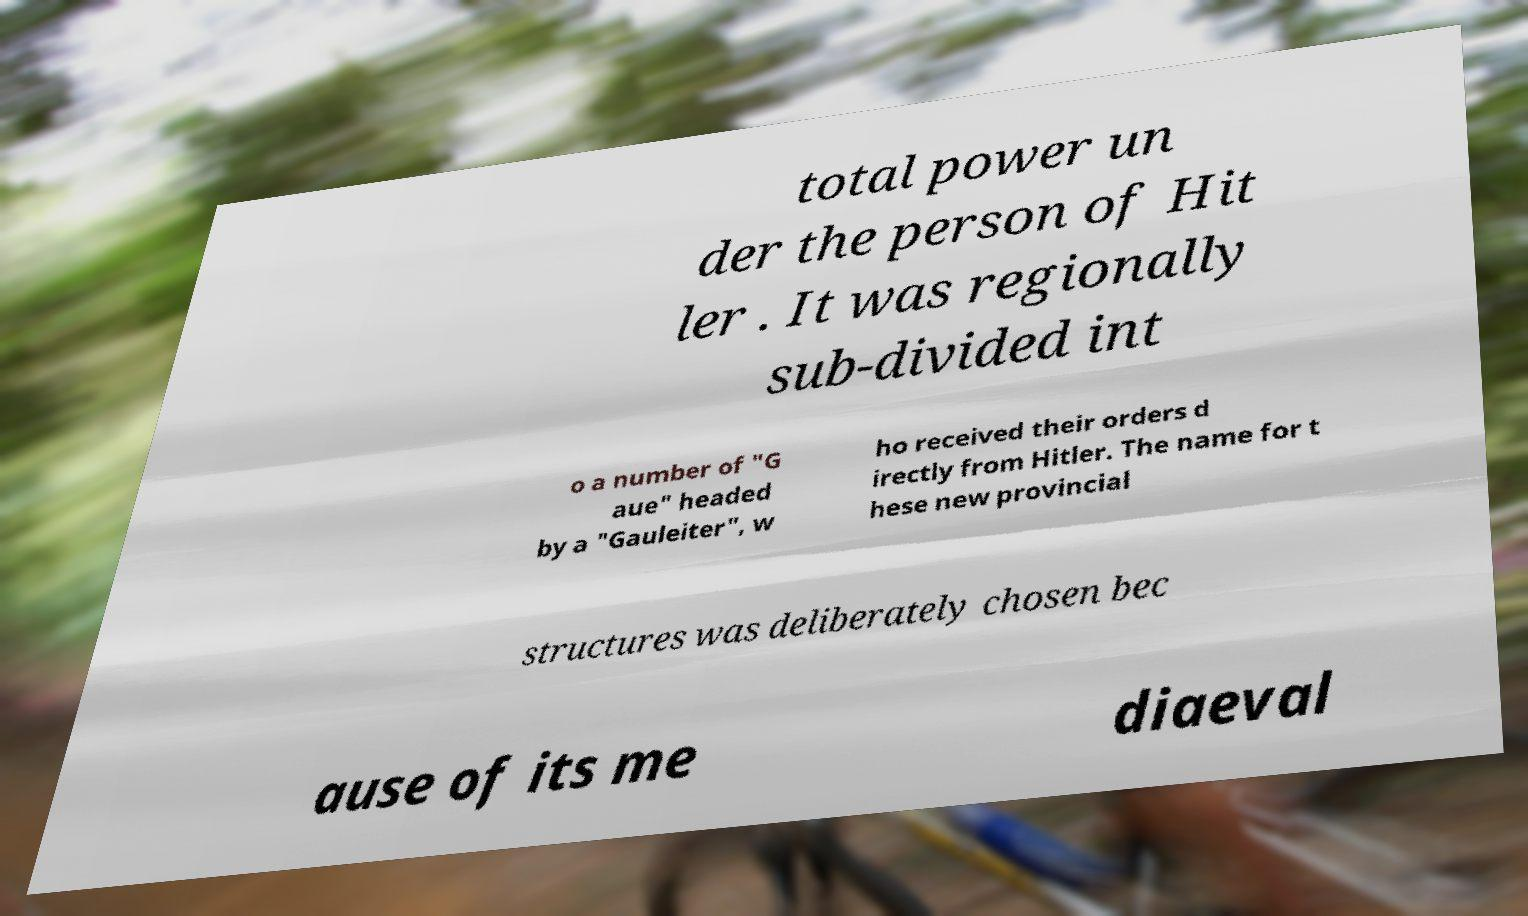Please read and relay the text visible in this image. What does it say? total power un der the person of Hit ler . It was regionally sub-divided int o a number of "G aue" headed by a "Gauleiter", w ho received their orders d irectly from Hitler. The name for t hese new provincial structures was deliberately chosen bec ause of its me diaeval 